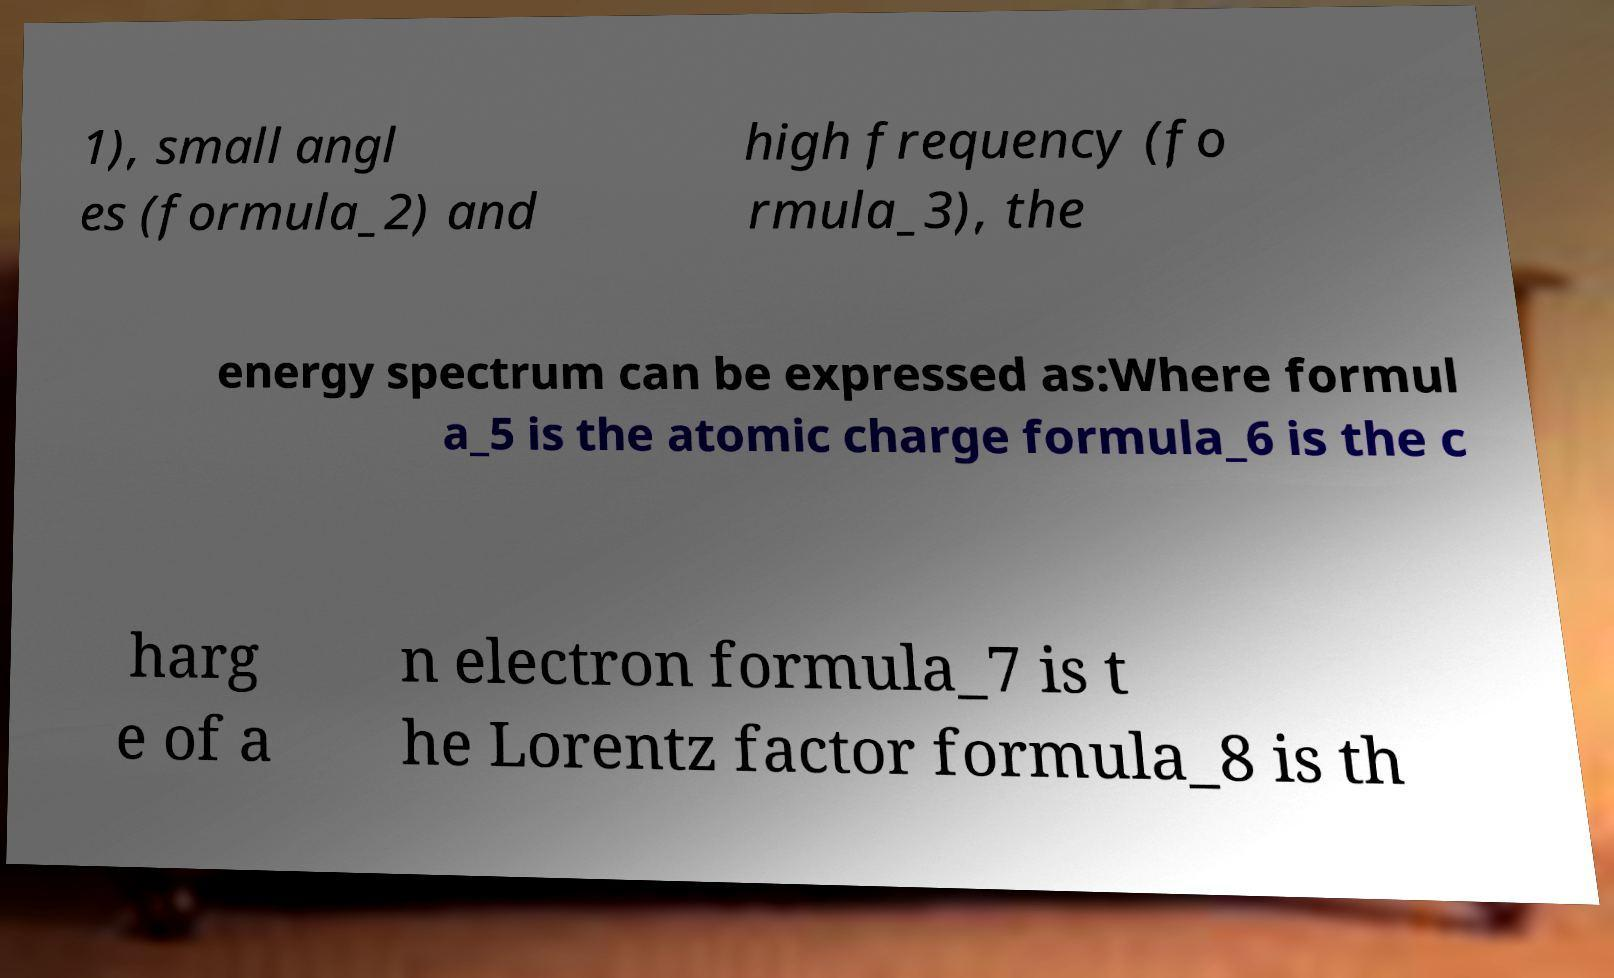Could you extract and type out the text from this image? 1), small angl es (formula_2) and high frequency (fo rmula_3), the energy spectrum can be expressed as:Where formul a_5 is the atomic charge formula_6 is the c harg e of a n electron formula_7 is t he Lorentz factor formula_8 is th 